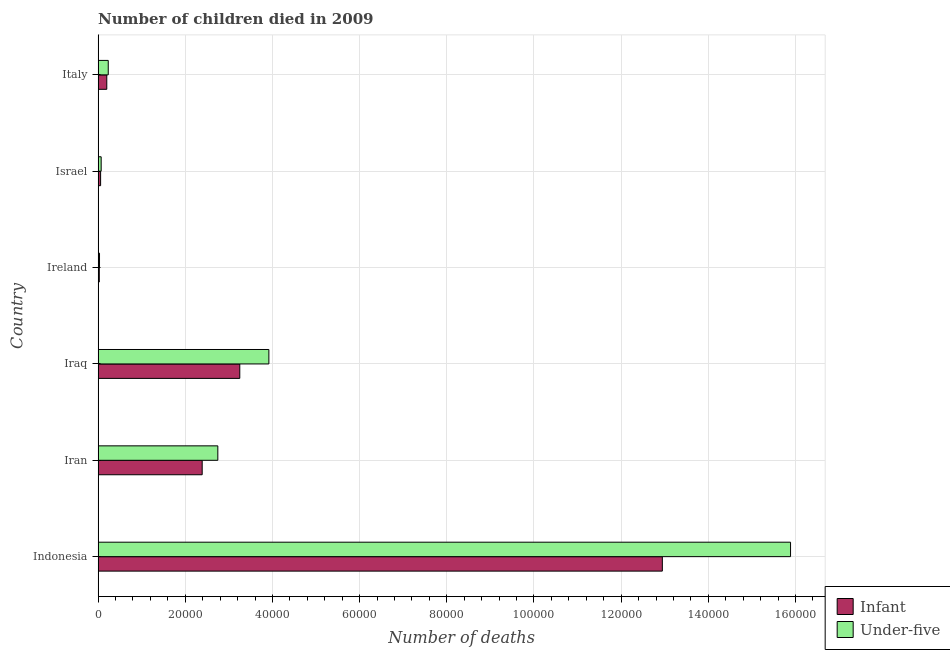How many different coloured bars are there?
Offer a very short reply. 2. How many bars are there on the 2nd tick from the top?
Provide a short and direct response. 2. How many bars are there on the 6th tick from the bottom?
Offer a very short reply. 2. In how many cases, is the number of bars for a given country not equal to the number of legend labels?
Give a very brief answer. 0. What is the number of infant deaths in Ireland?
Offer a terse response. 271. Across all countries, what is the maximum number of infant deaths?
Provide a succinct answer. 1.29e+05. Across all countries, what is the minimum number of infant deaths?
Offer a very short reply. 271. In which country was the number of under-five deaths minimum?
Your answer should be very brief. Ireland. What is the total number of infant deaths in the graph?
Give a very brief answer. 1.89e+05. What is the difference between the number of under-five deaths in Israel and that in Italy?
Your answer should be compact. -1625. What is the difference between the number of infant deaths in Iran and the number of under-five deaths in Ireland?
Your response must be concise. 2.36e+04. What is the average number of infant deaths per country?
Provide a succinct answer. 3.14e+04. What is the difference between the number of under-five deaths and number of infant deaths in Israel?
Your answer should be compact. 128. What is the ratio of the number of infant deaths in Indonesia to that in Iraq?
Your response must be concise. 3.98. Is the number of infant deaths in Iran less than that in Israel?
Your answer should be compact. No. What is the difference between the highest and the second highest number of infant deaths?
Keep it short and to the point. 9.70e+04. What is the difference between the highest and the lowest number of infant deaths?
Make the answer very short. 1.29e+05. In how many countries, is the number of under-five deaths greater than the average number of under-five deaths taken over all countries?
Offer a very short reply. 2. What does the 1st bar from the top in Iraq represents?
Your answer should be very brief. Under-five. What does the 2nd bar from the bottom in Indonesia represents?
Provide a short and direct response. Under-five. How many bars are there?
Your answer should be compact. 12. Are all the bars in the graph horizontal?
Offer a terse response. Yes. How many countries are there in the graph?
Your answer should be very brief. 6. What is the difference between two consecutive major ticks on the X-axis?
Your answer should be compact. 2.00e+04. What is the title of the graph?
Your answer should be compact. Number of children died in 2009. What is the label or title of the X-axis?
Offer a very short reply. Number of deaths. What is the label or title of the Y-axis?
Offer a very short reply. Country. What is the Number of deaths in Infant in Indonesia?
Your response must be concise. 1.29e+05. What is the Number of deaths of Under-five in Indonesia?
Offer a very short reply. 1.59e+05. What is the Number of deaths in Infant in Iran?
Provide a short and direct response. 2.39e+04. What is the Number of deaths in Under-five in Iran?
Your answer should be compact. 2.75e+04. What is the Number of deaths of Infant in Iraq?
Give a very brief answer. 3.25e+04. What is the Number of deaths in Under-five in Iraq?
Your answer should be compact. 3.92e+04. What is the Number of deaths in Infant in Ireland?
Offer a very short reply. 271. What is the Number of deaths in Under-five in Ireland?
Provide a short and direct response. 320. What is the Number of deaths of Infant in Israel?
Give a very brief answer. 572. What is the Number of deaths in Under-five in Israel?
Offer a very short reply. 700. What is the Number of deaths in Infant in Italy?
Your response must be concise. 1986. What is the Number of deaths in Under-five in Italy?
Your answer should be compact. 2325. Across all countries, what is the maximum Number of deaths of Infant?
Make the answer very short. 1.29e+05. Across all countries, what is the maximum Number of deaths in Under-five?
Your response must be concise. 1.59e+05. Across all countries, what is the minimum Number of deaths in Infant?
Give a very brief answer. 271. Across all countries, what is the minimum Number of deaths of Under-five?
Give a very brief answer. 320. What is the total Number of deaths of Infant in the graph?
Your response must be concise. 1.89e+05. What is the total Number of deaths of Under-five in the graph?
Your response must be concise. 2.29e+05. What is the difference between the Number of deaths of Infant in Indonesia and that in Iran?
Ensure brevity in your answer.  1.06e+05. What is the difference between the Number of deaths of Under-five in Indonesia and that in Iran?
Ensure brevity in your answer.  1.31e+05. What is the difference between the Number of deaths in Infant in Indonesia and that in Iraq?
Give a very brief answer. 9.70e+04. What is the difference between the Number of deaths in Under-five in Indonesia and that in Iraq?
Offer a terse response. 1.20e+05. What is the difference between the Number of deaths of Infant in Indonesia and that in Ireland?
Ensure brevity in your answer.  1.29e+05. What is the difference between the Number of deaths in Under-five in Indonesia and that in Ireland?
Your answer should be compact. 1.59e+05. What is the difference between the Number of deaths in Infant in Indonesia and that in Israel?
Provide a succinct answer. 1.29e+05. What is the difference between the Number of deaths of Under-five in Indonesia and that in Israel?
Your response must be concise. 1.58e+05. What is the difference between the Number of deaths of Infant in Indonesia and that in Italy?
Provide a short and direct response. 1.27e+05. What is the difference between the Number of deaths in Under-five in Indonesia and that in Italy?
Ensure brevity in your answer.  1.57e+05. What is the difference between the Number of deaths of Infant in Iran and that in Iraq?
Your response must be concise. -8626. What is the difference between the Number of deaths of Under-five in Iran and that in Iraq?
Keep it short and to the point. -1.17e+04. What is the difference between the Number of deaths in Infant in Iran and that in Ireland?
Provide a succinct answer. 2.36e+04. What is the difference between the Number of deaths in Under-five in Iran and that in Ireland?
Your answer should be very brief. 2.71e+04. What is the difference between the Number of deaths of Infant in Iran and that in Israel?
Make the answer very short. 2.33e+04. What is the difference between the Number of deaths of Under-five in Iran and that in Israel?
Keep it short and to the point. 2.68e+04. What is the difference between the Number of deaths in Infant in Iran and that in Italy?
Keep it short and to the point. 2.19e+04. What is the difference between the Number of deaths of Under-five in Iran and that in Italy?
Keep it short and to the point. 2.51e+04. What is the difference between the Number of deaths of Infant in Iraq and that in Ireland?
Give a very brief answer. 3.22e+04. What is the difference between the Number of deaths of Under-five in Iraq and that in Ireland?
Your response must be concise. 3.89e+04. What is the difference between the Number of deaths in Infant in Iraq and that in Israel?
Provide a succinct answer. 3.19e+04. What is the difference between the Number of deaths in Under-five in Iraq and that in Israel?
Offer a very short reply. 3.85e+04. What is the difference between the Number of deaths of Infant in Iraq and that in Italy?
Offer a very short reply. 3.05e+04. What is the difference between the Number of deaths of Under-five in Iraq and that in Italy?
Make the answer very short. 3.69e+04. What is the difference between the Number of deaths in Infant in Ireland and that in Israel?
Provide a succinct answer. -301. What is the difference between the Number of deaths of Under-five in Ireland and that in Israel?
Ensure brevity in your answer.  -380. What is the difference between the Number of deaths in Infant in Ireland and that in Italy?
Provide a short and direct response. -1715. What is the difference between the Number of deaths in Under-five in Ireland and that in Italy?
Give a very brief answer. -2005. What is the difference between the Number of deaths in Infant in Israel and that in Italy?
Your answer should be very brief. -1414. What is the difference between the Number of deaths in Under-five in Israel and that in Italy?
Keep it short and to the point. -1625. What is the difference between the Number of deaths in Infant in Indonesia and the Number of deaths in Under-five in Iran?
Your response must be concise. 1.02e+05. What is the difference between the Number of deaths of Infant in Indonesia and the Number of deaths of Under-five in Iraq?
Ensure brevity in your answer.  9.03e+04. What is the difference between the Number of deaths in Infant in Indonesia and the Number of deaths in Under-five in Ireland?
Make the answer very short. 1.29e+05. What is the difference between the Number of deaths in Infant in Indonesia and the Number of deaths in Under-five in Israel?
Provide a succinct answer. 1.29e+05. What is the difference between the Number of deaths of Infant in Indonesia and the Number of deaths of Under-five in Italy?
Keep it short and to the point. 1.27e+05. What is the difference between the Number of deaths in Infant in Iran and the Number of deaths in Under-five in Iraq?
Give a very brief answer. -1.53e+04. What is the difference between the Number of deaths in Infant in Iran and the Number of deaths in Under-five in Ireland?
Provide a succinct answer. 2.36e+04. What is the difference between the Number of deaths of Infant in Iran and the Number of deaths of Under-five in Israel?
Your answer should be very brief. 2.32e+04. What is the difference between the Number of deaths in Infant in Iran and the Number of deaths in Under-five in Italy?
Provide a short and direct response. 2.16e+04. What is the difference between the Number of deaths in Infant in Iraq and the Number of deaths in Under-five in Ireland?
Your answer should be very brief. 3.22e+04. What is the difference between the Number of deaths in Infant in Iraq and the Number of deaths in Under-five in Israel?
Provide a short and direct response. 3.18e+04. What is the difference between the Number of deaths in Infant in Iraq and the Number of deaths in Under-five in Italy?
Ensure brevity in your answer.  3.02e+04. What is the difference between the Number of deaths in Infant in Ireland and the Number of deaths in Under-five in Israel?
Your response must be concise. -429. What is the difference between the Number of deaths of Infant in Ireland and the Number of deaths of Under-five in Italy?
Your answer should be very brief. -2054. What is the difference between the Number of deaths in Infant in Israel and the Number of deaths in Under-five in Italy?
Your answer should be compact. -1753. What is the average Number of deaths of Infant per country?
Keep it short and to the point. 3.14e+04. What is the average Number of deaths in Under-five per country?
Provide a short and direct response. 3.81e+04. What is the difference between the Number of deaths of Infant and Number of deaths of Under-five in Indonesia?
Offer a terse response. -2.94e+04. What is the difference between the Number of deaths of Infant and Number of deaths of Under-five in Iran?
Offer a very short reply. -3590. What is the difference between the Number of deaths of Infant and Number of deaths of Under-five in Iraq?
Keep it short and to the point. -6676. What is the difference between the Number of deaths in Infant and Number of deaths in Under-five in Ireland?
Offer a terse response. -49. What is the difference between the Number of deaths in Infant and Number of deaths in Under-five in Israel?
Provide a short and direct response. -128. What is the difference between the Number of deaths of Infant and Number of deaths of Under-five in Italy?
Your answer should be compact. -339. What is the ratio of the Number of deaths in Infant in Indonesia to that in Iran?
Provide a succinct answer. 5.42. What is the ratio of the Number of deaths in Under-five in Indonesia to that in Iran?
Provide a succinct answer. 5.78. What is the ratio of the Number of deaths in Infant in Indonesia to that in Iraq?
Keep it short and to the point. 3.98. What is the ratio of the Number of deaths of Under-five in Indonesia to that in Iraq?
Your answer should be very brief. 4.05. What is the ratio of the Number of deaths of Infant in Indonesia to that in Ireland?
Make the answer very short. 477.69. What is the ratio of the Number of deaths of Under-five in Indonesia to that in Ireland?
Ensure brevity in your answer.  496.47. What is the ratio of the Number of deaths in Infant in Indonesia to that in Israel?
Your answer should be very brief. 226.32. What is the ratio of the Number of deaths in Under-five in Indonesia to that in Israel?
Keep it short and to the point. 226.96. What is the ratio of the Number of deaths of Infant in Indonesia to that in Italy?
Keep it short and to the point. 65.18. What is the ratio of the Number of deaths in Under-five in Indonesia to that in Italy?
Provide a short and direct response. 68.33. What is the ratio of the Number of deaths of Infant in Iran to that in Iraq?
Offer a terse response. 0.73. What is the ratio of the Number of deaths of Under-five in Iran to that in Iraq?
Ensure brevity in your answer.  0.7. What is the ratio of the Number of deaths of Infant in Iran to that in Ireland?
Provide a short and direct response. 88.11. What is the ratio of the Number of deaths of Under-five in Iran to that in Ireland?
Offer a very short reply. 85.83. What is the ratio of the Number of deaths in Infant in Iran to that in Israel?
Your response must be concise. 41.74. What is the ratio of the Number of deaths of Under-five in Iran to that in Israel?
Provide a short and direct response. 39.24. What is the ratio of the Number of deaths in Infant in Iran to that in Italy?
Ensure brevity in your answer.  12.02. What is the ratio of the Number of deaths in Under-five in Iran to that in Italy?
Your answer should be compact. 11.81. What is the ratio of the Number of deaths in Infant in Iraq to that in Ireland?
Your answer should be very brief. 119.94. What is the ratio of the Number of deaths of Under-five in Iraq to that in Ireland?
Provide a succinct answer. 122.43. What is the ratio of the Number of deaths of Infant in Iraq to that in Israel?
Your answer should be very brief. 56.82. What is the ratio of the Number of deaths of Under-five in Iraq to that in Israel?
Provide a short and direct response. 55.97. What is the ratio of the Number of deaths of Infant in Iraq to that in Italy?
Offer a very short reply. 16.37. What is the ratio of the Number of deaths in Under-five in Iraq to that in Italy?
Offer a terse response. 16.85. What is the ratio of the Number of deaths in Infant in Ireland to that in Israel?
Make the answer very short. 0.47. What is the ratio of the Number of deaths of Under-five in Ireland to that in Israel?
Ensure brevity in your answer.  0.46. What is the ratio of the Number of deaths of Infant in Ireland to that in Italy?
Ensure brevity in your answer.  0.14. What is the ratio of the Number of deaths in Under-five in Ireland to that in Italy?
Provide a short and direct response. 0.14. What is the ratio of the Number of deaths in Infant in Israel to that in Italy?
Offer a very short reply. 0.29. What is the ratio of the Number of deaths in Under-five in Israel to that in Italy?
Provide a short and direct response. 0.3. What is the difference between the highest and the second highest Number of deaths in Infant?
Offer a terse response. 9.70e+04. What is the difference between the highest and the second highest Number of deaths in Under-five?
Make the answer very short. 1.20e+05. What is the difference between the highest and the lowest Number of deaths in Infant?
Provide a succinct answer. 1.29e+05. What is the difference between the highest and the lowest Number of deaths in Under-five?
Your answer should be very brief. 1.59e+05. 